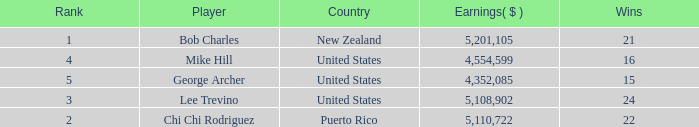On average, how many wins have a rank lower than 1? None. 